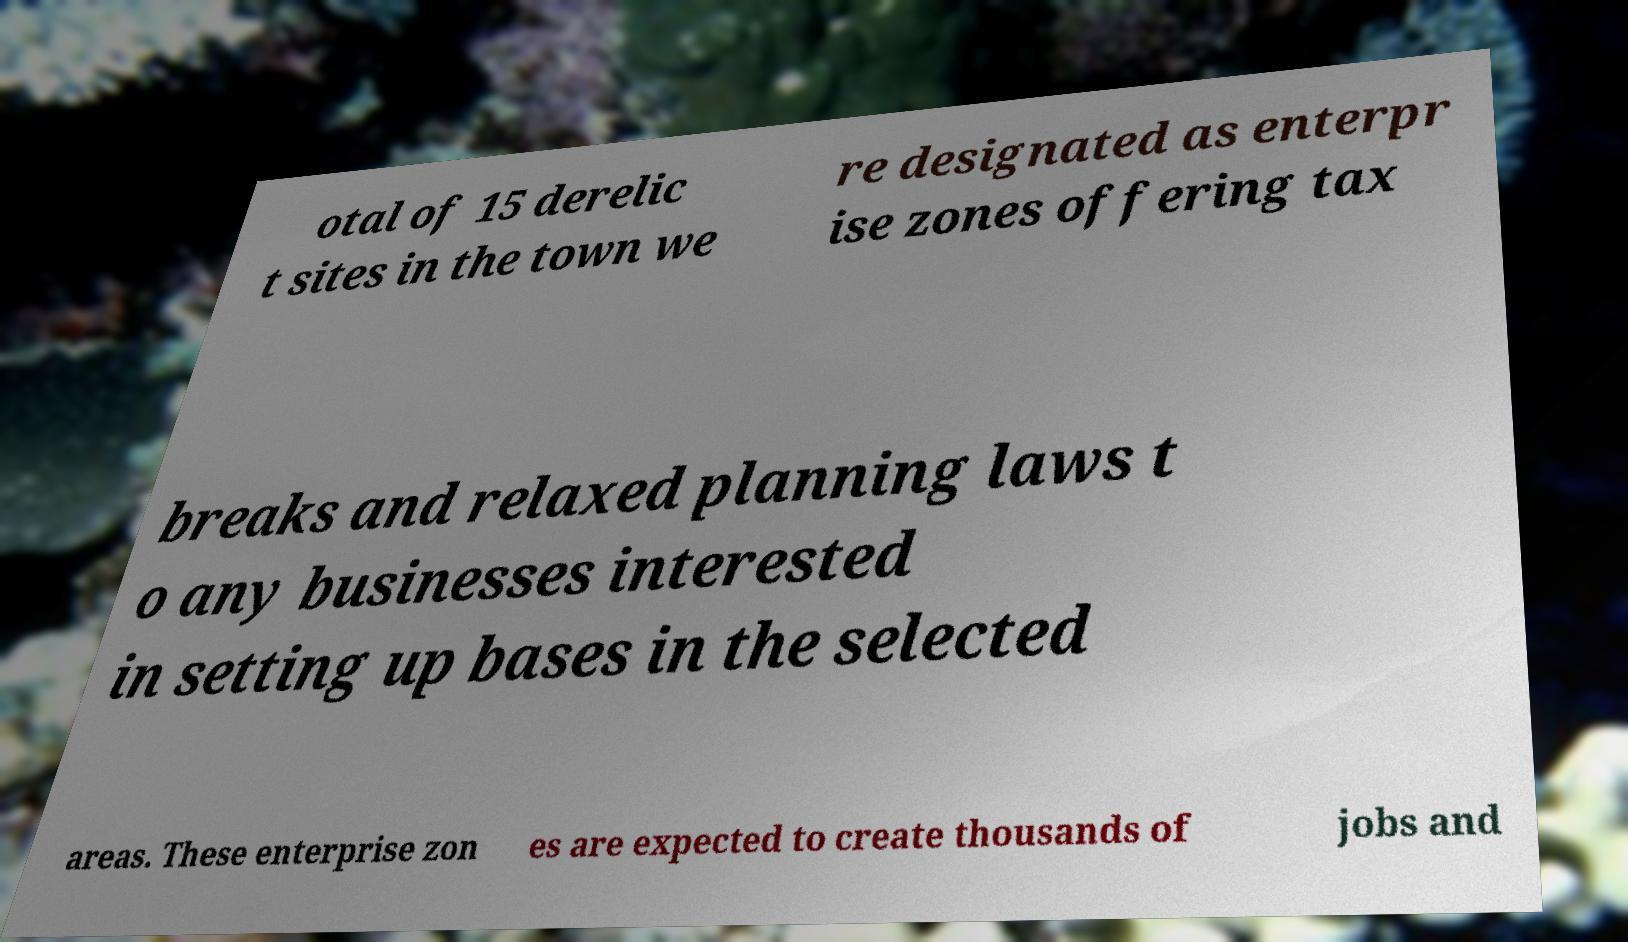Could you extract and type out the text from this image? otal of 15 derelic t sites in the town we re designated as enterpr ise zones offering tax breaks and relaxed planning laws t o any businesses interested in setting up bases in the selected areas. These enterprise zon es are expected to create thousands of jobs and 